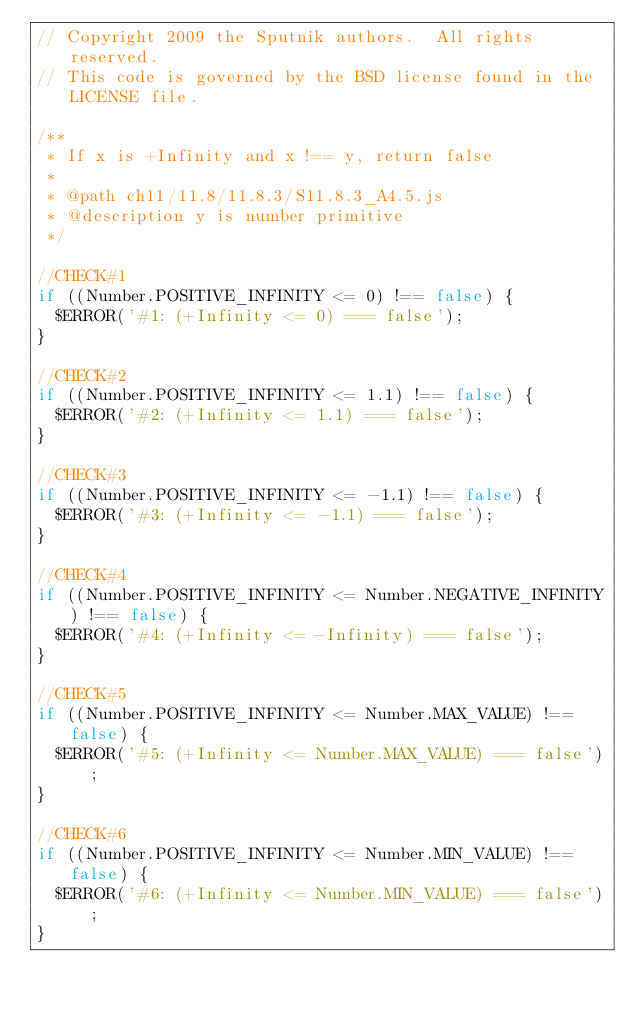Convert code to text. <code><loc_0><loc_0><loc_500><loc_500><_JavaScript_>// Copyright 2009 the Sputnik authors.  All rights reserved.
// This code is governed by the BSD license found in the LICENSE file.

/**
 * If x is +Infinity and x !== y, return false
 *
 * @path ch11/11.8/11.8.3/S11.8.3_A4.5.js
 * @description y is number primitive
 */

//CHECK#1
if ((Number.POSITIVE_INFINITY <= 0) !== false) {
  $ERROR('#1: (+Infinity <= 0) === false');
}

//CHECK#2
if ((Number.POSITIVE_INFINITY <= 1.1) !== false) {
  $ERROR('#2: (+Infinity <= 1.1) === false');
}

//CHECK#3
if ((Number.POSITIVE_INFINITY <= -1.1) !== false) {
  $ERROR('#3: (+Infinity <= -1.1) === false');
}

//CHECK#4
if ((Number.POSITIVE_INFINITY <= Number.NEGATIVE_INFINITY) !== false) {
  $ERROR('#4: (+Infinity <= -Infinity) === false');
}

//CHECK#5
if ((Number.POSITIVE_INFINITY <= Number.MAX_VALUE) !== false) {
  $ERROR('#5: (+Infinity <= Number.MAX_VALUE) === false');
}

//CHECK#6
if ((Number.POSITIVE_INFINITY <= Number.MIN_VALUE) !== false) {
  $ERROR('#6: (+Infinity <= Number.MIN_VALUE) === false');
}


</code> 